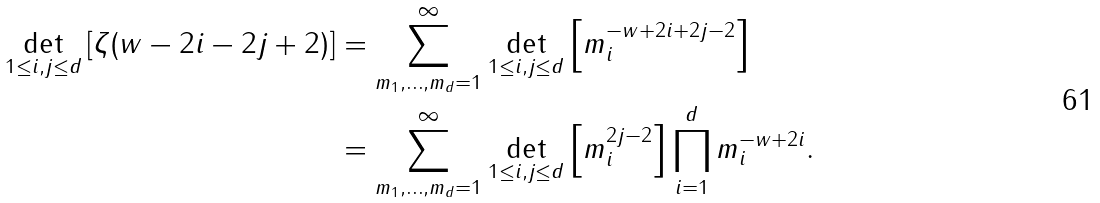<formula> <loc_0><loc_0><loc_500><loc_500>\det _ { 1 \leq i , j \leq d } \left [ \zeta ( w - 2 i - 2 j + 2 ) \right ] & = \sum _ { m _ { 1 } , \dots , m _ { d } = 1 } ^ { \infty } \det _ { 1 \leq i , j \leq d } \left [ m _ { i } ^ { - w + 2 i + 2 j - 2 } \right ] \\ & = \sum _ { m _ { 1 } , \dots , m _ { d } = 1 } ^ { \infty } \det _ { 1 \leq i , j \leq d } \left [ m _ { i } ^ { 2 j - 2 } \right ] \prod _ { i = 1 } ^ { d } m _ { i } ^ { - w + 2 i } .</formula> 